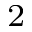<formula> <loc_0><loc_0><loc_500><loc_500>_ { 2 }</formula> 